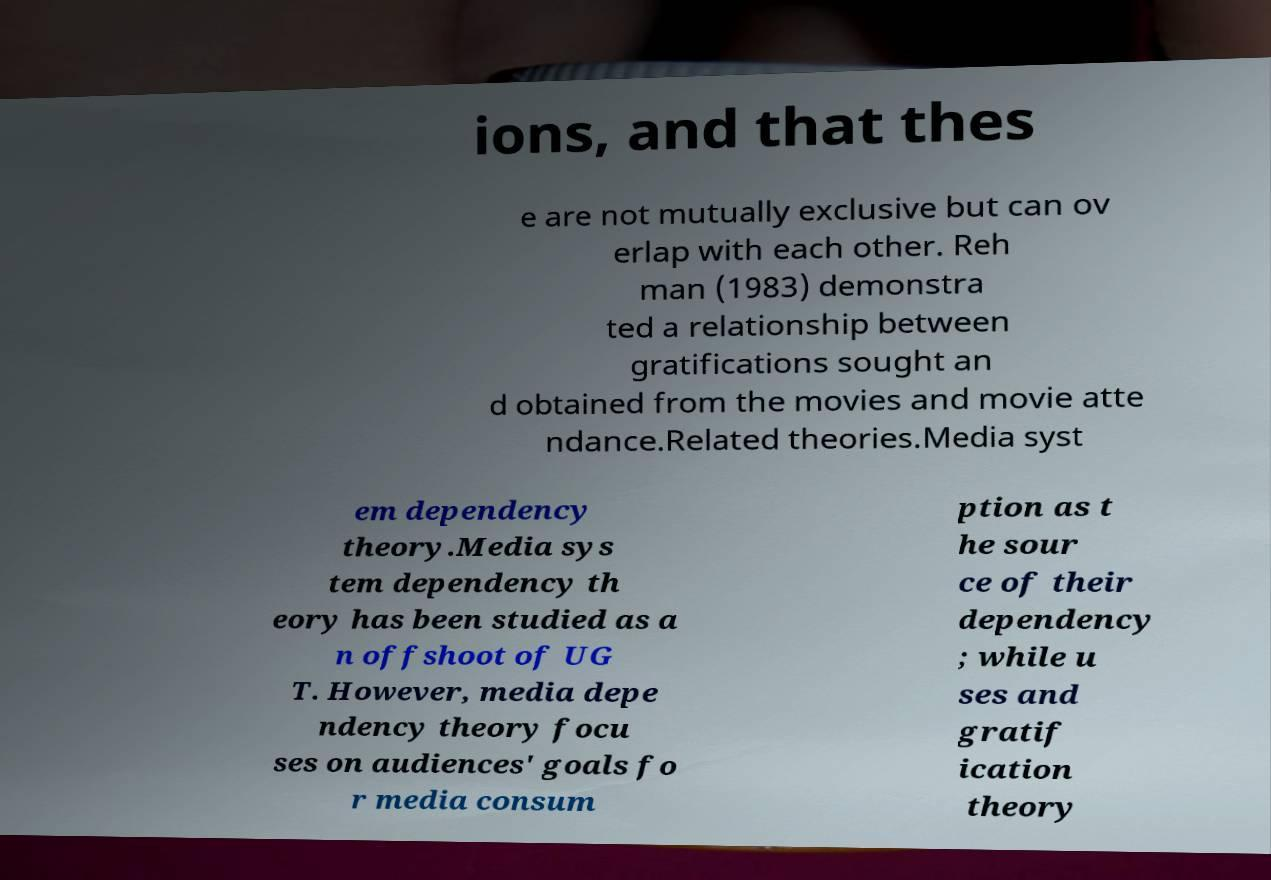Could you assist in decoding the text presented in this image and type it out clearly? ions, and that thes e are not mutually exclusive but can ov erlap with each other. Reh man (1983) demonstra ted a relationship between gratifications sought an d obtained from the movies and movie atte ndance.Related theories.Media syst em dependency theory.Media sys tem dependency th eory has been studied as a n offshoot of UG T. However, media depe ndency theory focu ses on audiences' goals fo r media consum ption as t he sour ce of their dependency ; while u ses and gratif ication theory 